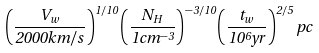Convert formula to latex. <formula><loc_0><loc_0><loc_500><loc_500>\left ( \frac { V _ { w } } { 2 0 0 0 k m / s } \right ) ^ { 1 / 1 0 } \left ( \frac { N _ { H } } { 1 c m ^ { - 3 } } \right ) ^ { - 3 / 1 0 } \left ( \frac { t _ { w } } { 1 0 ^ { 6 } y r } \right ) ^ { 2 / 5 } p c</formula> 